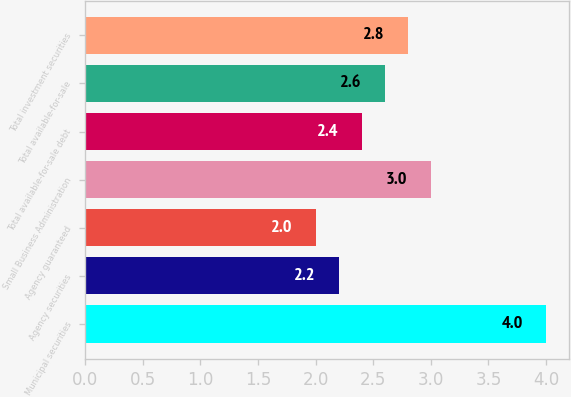Convert chart to OTSL. <chart><loc_0><loc_0><loc_500><loc_500><bar_chart><fcel>Municipal securities<fcel>Agency securities<fcel>Agency guaranteed<fcel>Small Business Administration<fcel>Total available-for-sale debt<fcel>Total available-for-sale<fcel>Total investment securities<nl><fcel>4<fcel>2.2<fcel>2<fcel>3<fcel>2.4<fcel>2.6<fcel>2.8<nl></chart> 